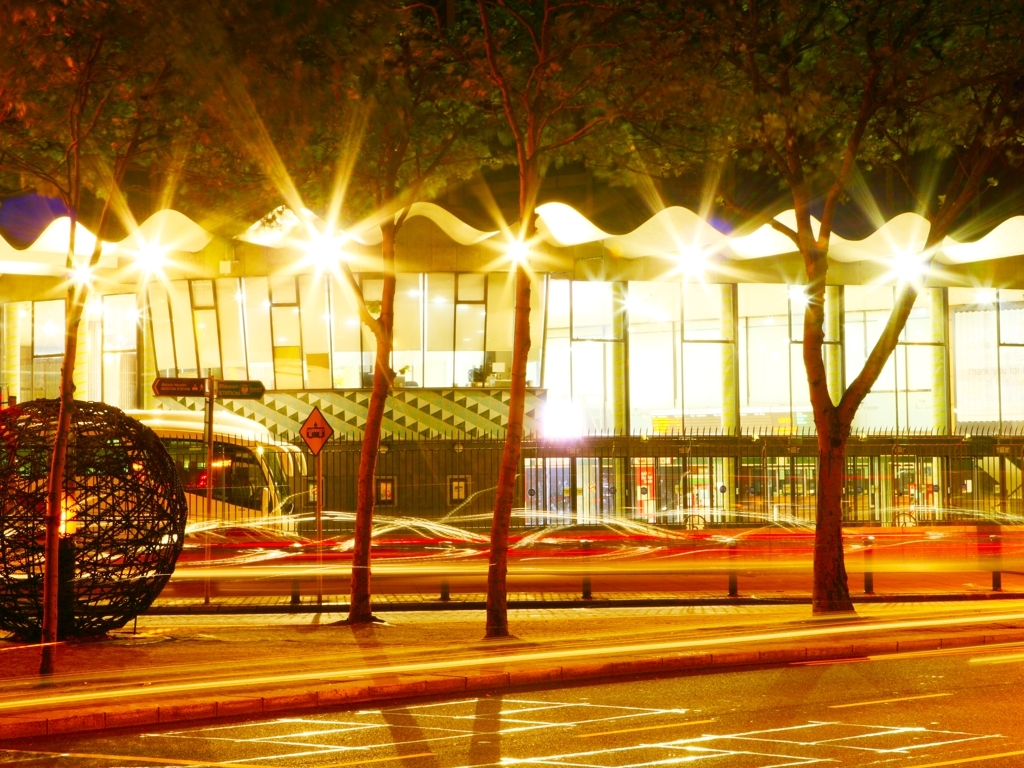Does this photo have a high level of clarity? The photo appears to be taken with a longer exposure, which captures the stationary objects with high clarity, such as trees and buildings, while the moving light sources, such as vehicle headlights, create light trails that convey motion. The combination of clear elements and intentional streaks of light provides an artistic take on clarity which contributes to a vibrant city scene. 